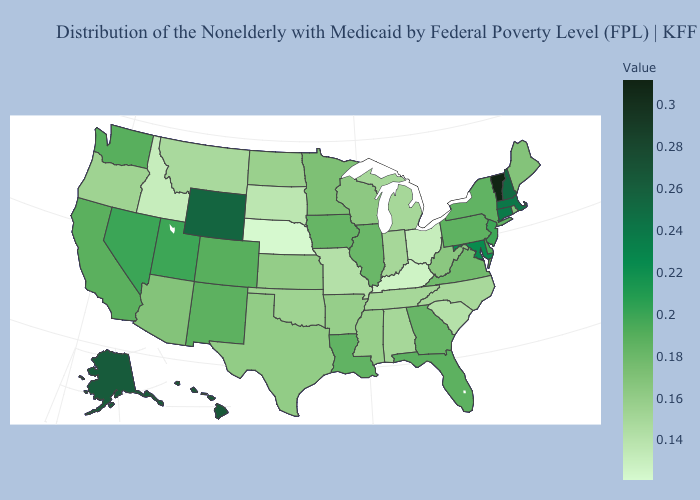Which states have the lowest value in the USA?
Write a very short answer. Nebraska. Among the states that border Texas , does New Mexico have the highest value?
Write a very short answer. Yes. Which states have the highest value in the USA?
Short answer required. Vermont. Does the map have missing data?
Quick response, please. No. 